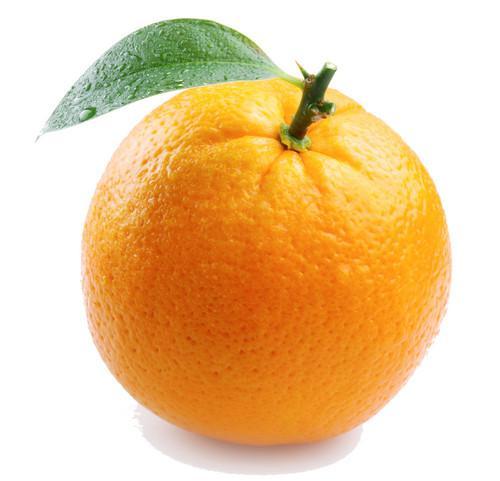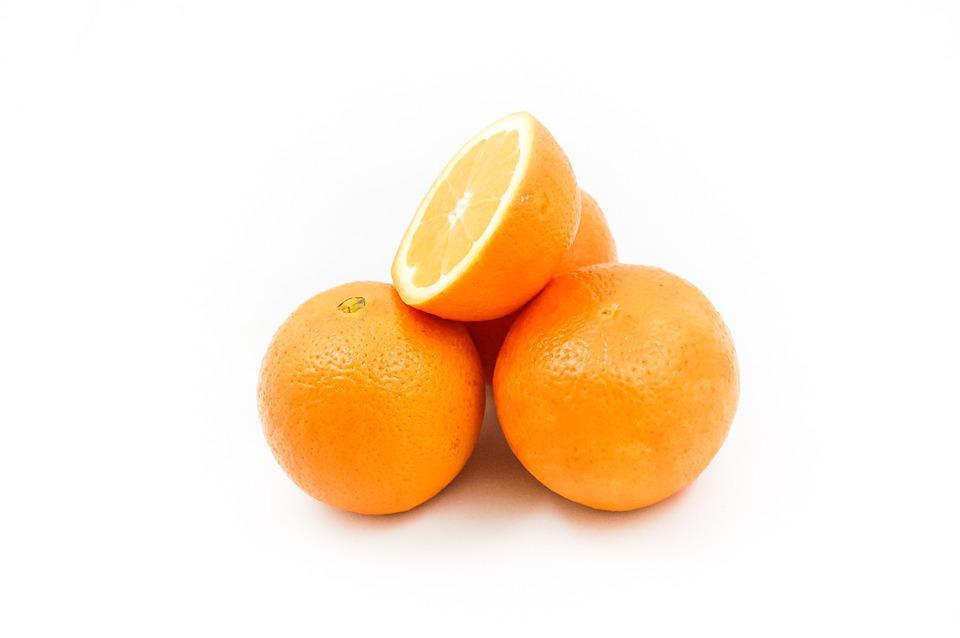The first image is the image on the left, the second image is the image on the right. Examine the images to the left and right. Is the description "Glasses of orange juice without straws in them are present in at least one image." accurate? Answer yes or no. No. The first image is the image on the left, the second image is the image on the right. Analyze the images presented: Is the assertion "An orange WEDGE rests against a glass of juice." valid? Answer yes or no. No. 